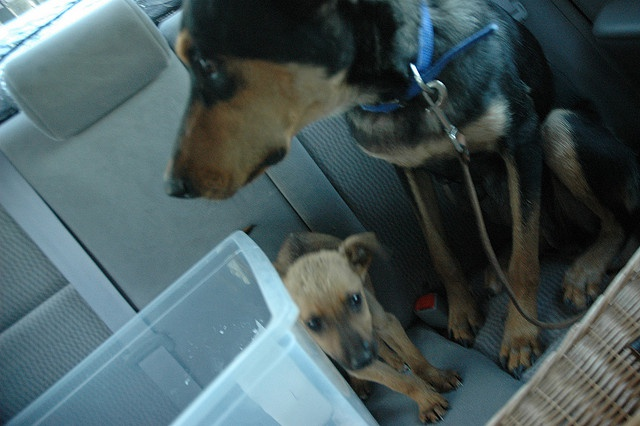Describe the objects in this image and their specific colors. I can see car in darkgray, gray, and black tones, dog in darkgray, black, gray, darkgreen, and blue tones, and dog in darkgray, gray, and black tones in this image. 